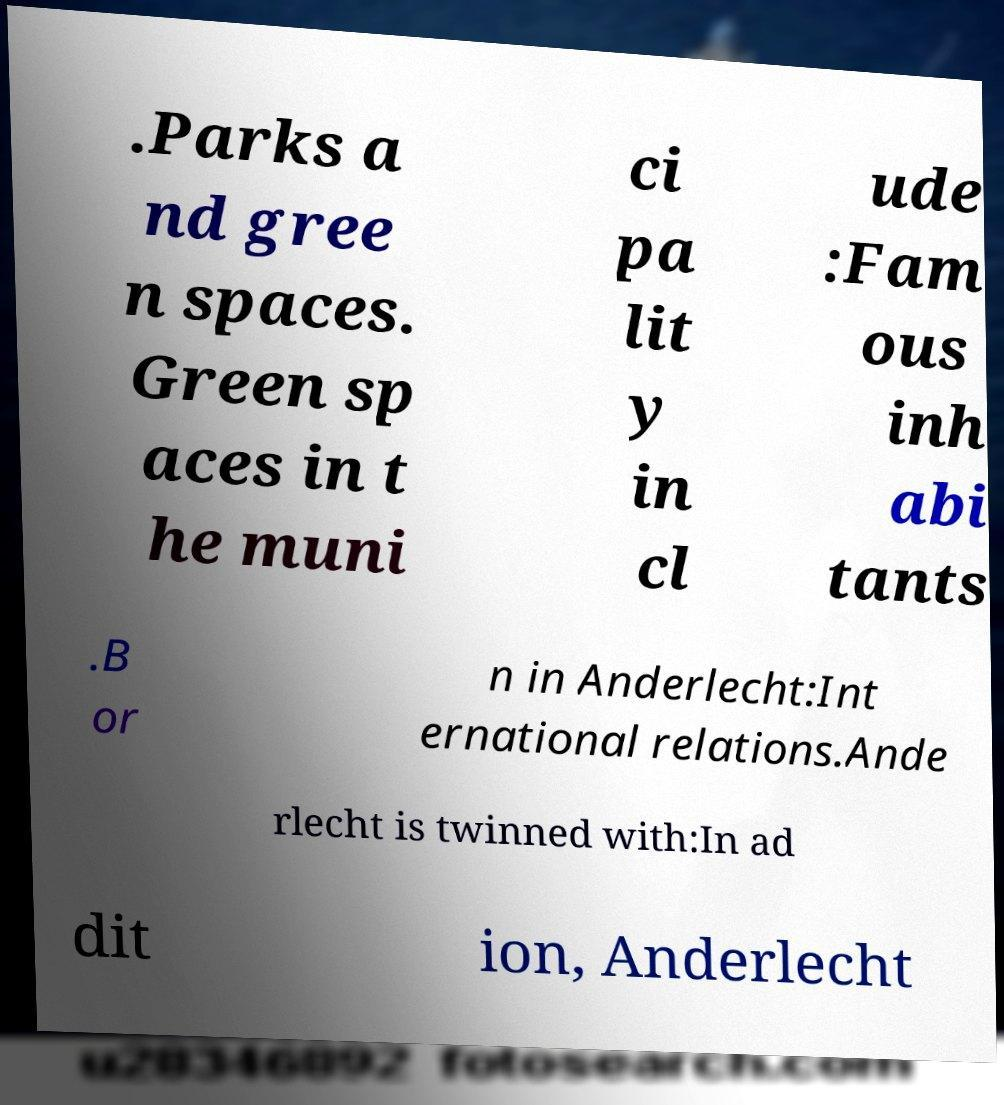There's text embedded in this image that I need extracted. Can you transcribe it verbatim? .Parks a nd gree n spaces. Green sp aces in t he muni ci pa lit y in cl ude :Fam ous inh abi tants .B or n in Anderlecht:Int ernational relations.Ande rlecht is twinned with:In ad dit ion, Anderlecht 